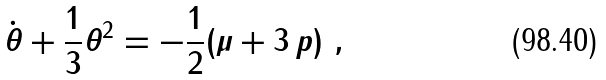Convert formula to latex. <formula><loc_0><loc_0><loc_500><loc_500>\dot { \theta } + \frac { 1 } { 3 } \theta ^ { 2 } = - \frac { 1 } { 2 } ( \mu + 3 \, p ) \ ,</formula> 